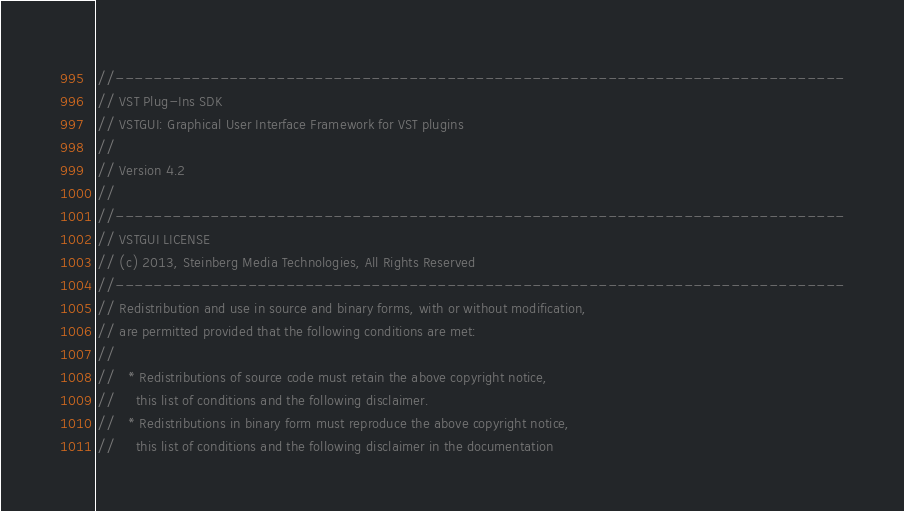Convert code to text. <code><loc_0><loc_0><loc_500><loc_500><_ObjectiveC_>//-----------------------------------------------------------------------------
// VST Plug-Ins SDK
// VSTGUI: Graphical User Interface Framework for VST plugins
//
// Version 4.2
//
//-----------------------------------------------------------------------------
// VSTGUI LICENSE
// (c) 2013, Steinberg Media Technologies, All Rights Reserved
//-----------------------------------------------------------------------------
// Redistribution and use in source and binary forms, with or without modification,
// are permitted provided that the following conditions are met:
// 
//   * Redistributions of source code must retain the above copyright notice, 
//     this list of conditions and the following disclaimer.
//   * Redistributions in binary form must reproduce the above copyright notice,
//     this list of conditions and the following disclaimer in the documentation </code> 